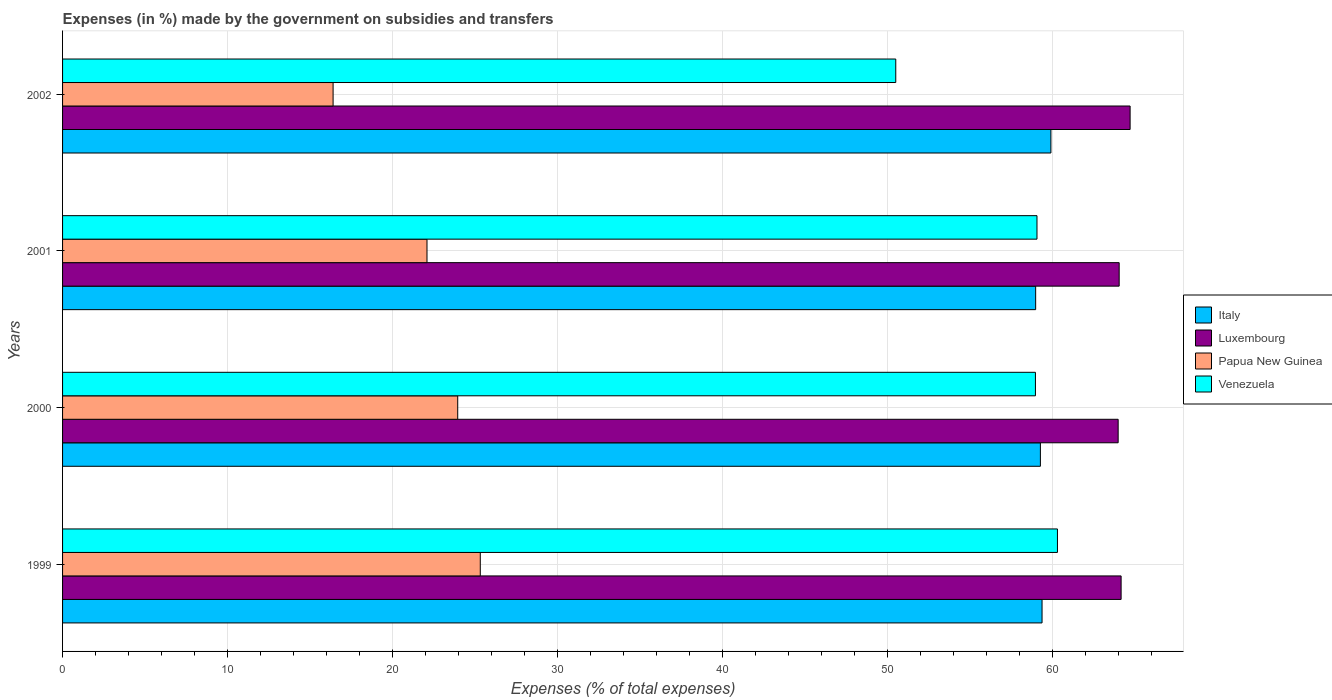How many different coloured bars are there?
Provide a succinct answer. 4. How many groups of bars are there?
Ensure brevity in your answer.  4. How many bars are there on the 3rd tick from the top?
Keep it short and to the point. 4. How many bars are there on the 3rd tick from the bottom?
Make the answer very short. 4. What is the label of the 3rd group of bars from the top?
Your response must be concise. 2000. What is the percentage of expenses made by the government on subsidies and transfers in Luxembourg in 2002?
Provide a succinct answer. 64.71. Across all years, what is the maximum percentage of expenses made by the government on subsidies and transfers in Venezuela?
Your answer should be very brief. 60.3. Across all years, what is the minimum percentage of expenses made by the government on subsidies and transfers in Luxembourg?
Make the answer very short. 63.98. What is the total percentage of expenses made by the government on subsidies and transfers in Papua New Guinea in the graph?
Provide a succinct answer. 87.76. What is the difference between the percentage of expenses made by the government on subsidies and transfers in Italy in 1999 and that in 2000?
Offer a terse response. 0.1. What is the difference between the percentage of expenses made by the government on subsidies and transfers in Papua New Guinea in 2000 and the percentage of expenses made by the government on subsidies and transfers in Italy in 2002?
Your answer should be compact. -35.96. What is the average percentage of expenses made by the government on subsidies and transfers in Luxembourg per year?
Make the answer very short. 64.23. In the year 2001, what is the difference between the percentage of expenses made by the government on subsidies and transfers in Papua New Guinea and percentage of expenses made by the government on subsidies and transfers in Italy?
Keep it short and to the point. -36.89. What is the ratio of the percentage of expenses made by the government on subsidies and transfers in Italy in 1999 to that in 2001?
Ensure brevity in your answer.  1.01. What is the difference between the highest and the second highest percentage of expenses made by the government on subsidies and transfers in Papua New Guinea?
Ensure brevity in your answer.  1.37. What is the difference between the highest and the lowest percentage of expenses made by the government on subsidies and transfers in Venezuela?
Your answer should be compact. 9.8. In how many years, is the percentage of expenses made by the government on subsidies and transfers in Luxembourg greater than the average percentage of expenses made by the government on subsidies and transfers in Luxembourg taken over all years?
Your answer should be compact. 1. Is it the case that in every year, the sum of the percentage of expenses made by the government on subsidies and transfers in Papua New Guinea and percentage of expenses made by the government on subsidies and transfers in Italy is greater than the sum of percentage of expenses made by the government on subsidies and transfers in Venezuela and percentage of expenses made by the government on subsidies and transfers in Luxembourg?
Provide a succinct answer. No. What does the 4th bar from the top in 2001 represents?
Make the answer very short. Italy. How many bars are there?
Give a very brief answer. 16. How many years are there in the graph?
Your answer should be compact. 4. How many legend labels are there?
Your answer should be very brief. 4. How are the legend labels stacked?
Ensure brevity in your answer.  Vertical. What is the title of the graph?
Ensure brevity in your answer.  Expenses (in %) made by the government on subsidies and transfers. Does "Puerto Rico" appear as one of the legend labels in the graph?
Provide a short and direct response. No. What is the label or title of the X-axis?
Offer a very short reply. Expenses (% of total expenses). What is the Expenses (% of total expenses) in Italy in 1999?
Make the answer very short. 59.37. What is the Expenses (% of total expenses) in Luxembourg in 1999?
Your response must be concise. 64.16. What is the Expenses (% of total expenses) in Papua New Guinea in 1999?
Offer a very short reply. 25.32. What is the Expenses (% of total expenses) of Venezuela in 1999?
Keep it short and to the point. 60.3. What is the Expenses (% of total expenses) in Italy in 2000?
Give a very brief answer. 59.27. What is the Expenses (% of total expenses) of Luxembourg in 2000?
Your answer should be compact. 63.98. What is the Expenses (% of total expenses) in Papua New Guinea in 2000?
Make the answer very short. 23.95. What is the Expenses (% of total expenses) in Venezuela in 2000?
Ensure brevity in your answer.  58.97. What is the Expenses (% of total expenses) in Italy in 2001?
Offer a terse response. 58.98. What is the Expenses (% of total expenses) in Luxembourg in 2001?
Offer a very short reply. 64.05. What is the Expenses (% of total expenses) of Papua New Guinea in 2001?
Offer a very short reply. 22.09. What is the Expenses (% of total expenses) in Venezuela in 2001?
Provide a succinct answer. 59.06. What is the Expenses (% of total expenses) of Italy in 2002?
Make the answer very short. 59.91. What is the Expenses (% of total expenses) of Luxembourg in 2002?
Make the answer very short. 64.71. What is the Expenses (% of total expenses) in Papua New Guinea in 2002?
Your answer should be compact. 16.4. What is the Expenses (% of total expenses) in Venezuela in 2002?
Offer a terse response. 50.5. Across all years, what is the maximum Expenses (% of total expenses) in Italy?
Your answer should be very brief. 59.91. Across all years, what is the maximum Expenses (% of total expenses) of Luxembourg?
Your response must be concise. 64.71. Across all years, what is the maximum Expenses (% of total expenses) of Papua New Guinea?
Provide a succinct answer. 25.32. Across all years, what is the maximum Expenses (% of total expenses) of Venezuela?
Give a very brief answer. 60.3. Across all years, what is the minimum Expenses (% of total expenses) of Italy?
Provide a succinct answer. 58.98. Across all years, what is the minimum Expenses (% of total expenses) of Luxembourg?
Ensure brevity in your answer.  63.98. Across all years, what is the minimum Expenses (% of total expenses) of Papua New Guinea?
Ensure brevity in your answer.  16.4. Across all years, what is the minimum Expenses (% of total expenses) in Venezuela?
Your answer should be very brief. 50.5. What is the total Expenses (% of total expenses) of Italy in the graph?
Provide a succinct answer. 237.53. What is the total Expenses (% of total expenses) in Luxembourg in the graph?
Your answer should be very brief. 256.9. What is the total Expenses (% of total expenses) in Papua New Guinea in the graph?
Your answer should be very brief. 87.76. What is the total Expenses (% of total expenses) in Venezuela in the graph?
Give a very brief answer. 228.84. What is the difference between the Expenses (% of total expenses) in Italy in 1999 and that in 2000?
Ensure brevity in your answer.  0.1. What is the difference between the Expenses (% of total expenses) in Luxembourg in 1999 and that in 2000?
Ensure brevity in your answer.  0.18. What is the difference between the Expenses (% of total expenses) in Papua New Guinea in 1999 and that in 2000?
Keep it short and to the point. 1.37. What is the difference between the Expenses (% of total expenses) in Venezuela in 1999 and that in 2000?
Give a very brief answer. 1.33. What is the difference between the Expenses (% of total expenses) in Italy in 1999 and that in 2001?
Offer a terse response. 0.39. What is the difference between the Expenses (% of total expenses) in Luxembourg in 1999 and that in 2001?
Offer a terse response. 0.12. What is the difference between the Expenses (% of total expenses) in Papua New Guinea in 1999 and that in 2001?
Your response must be concise. 3.23. What is the difference between the Expenses (% of total expenses) in Venezuela in 1999 and that in 2001?
Offer a terse response. 1.24. What is the difference between the Expenses (% of total expenses) of Italy in 1999 and that in 2002?
Your answer should be very brief. -0.54. What is the difference between the Expenses (% of total expenses) in Luxembourg in 1999 and that in 2002?
Your response must be concise. -0.55. What is the difference between the Expenses (% of total expenses) in Papua New Guinea in 1999 and that in 2002?
Make the answer very short. 8.92. What is the difference between the Expenses (% of total expenses) of Venezuela in 1999 and that in 2002?
Offer a terse response. 9.8. What is the difference between the Expenses (% of total expenses) of Italy in 2000 and that in 2001?
Offer a very short reply. 0.29. What is the difference between the Expenses (% of total expenses) of Luxembourg in 2000 and that in 2001?
Provide a short and direct response. -0.06. What is the difference between the Expenses (% of total expenses) in Papua New Guinea in 2000 and that in 2001?
Your answer should be compact. 1.86. What is the difference between the Expenses (% of total expenses) in Venezuela in 2000 and that in 2001?
Offer a terse response. -0.09. What is the difference between the Expenses (% of total expenses) of Italy in 2000 and that in 2002?
Offer a very short reply. -0.64. What is the difference between the Expenses (% of total expenses) of Luxembourg in 2000 and that in 2002?
Make the answer very short. -0.73. What is the difference between the Expenses (% of total expenses) of Papua New Guinea in 2000 and that in 2002?
Provide a succinct answer. 7.55. What is the difference between the Expenses (% of total expenses) of Venezuela in 2000 and that in 2002?
Ensure brevity in your answer.  8.47. What is the difference between the Expenses (% of total expenses) in Italy in 2001 and that in 2002?
Offer a very short reply. -0.92. What is the difference between the Expenses (% of total expenses) of Luxembourg in 2001 and that in 2002?
Keep it short and to the point. -0.66. What is the difference between the Expenses (% of total expenses) of Papua New Guinea in 2001 and that in 2002?
Offer a very short reply. 5.69. What is the difference between the Expenses (% of total expenses) of Venezuela in 2001 and that in 2002?
Offer a very short reply. 8.56. What is the difference between the Expenses (% of total expenses) in Italy in 1999 and the Expenses (% of total expenses) in Luxembourg in 2000?
Provide a short and direct response. -4.61. What is the difference between the Expenses (% of total expenses) in Italy in 1999 and the Expenses (% of total expenses) in Papua New Guinea in 2000?
Give a very brief answer. 35.42. What is the difference between the Expenses (% of total expenses) in Italy in 1999 and the Expenses (% of total expenses) in Venezuela in 2000?
Offer a terse response. 0.4. What is the difference between the Expenses (% of total expenses) in Luxembourg in 1999 and the Expenses (% of total expenses) in Papua New Guinea in 2000?
Your answer should be compact. 40.21. What is the difference between the Expenses (% of total expenses) of Luxembourg in 1999 and the Expenses (% of total expenses) of Venezuela in 2000?
Your answer should be very brief. 5.19. What is the difference between the Expenses (% of total expenses) in Papua New Guinea in 1999 and the Expenses (% of total expenses) in Venezuela in 2000?
Provide a short and direct response. -33.65. What is the difference between the Expenses (% of total expenses) of Italy in 1999 and the Expenses (% of total expenses) of Luxembourg in 2001?
Make the answer very short. -4.67. What is the difference between the Expenses (% of total expenses) of Italy in 1999 and the Expenses (% of total expenses) of Papua New Guinea in 2001?
Provide a succinct answer. 37.28. What is the difference between the Expenses (% of total expenses) in Italy in 1999 and the Expenses (% of total expenses) in Venezuela in 2001?
Offer a very short reply. 0.31. What is the difference between the Expenses (% of total expenses) of Luxembourg in 1999 and the Expenses (% of total expenses) of Papua New Guinea in 2001?
Offer a very short reply. 42.07. What is the difference between the Expenses (% of total expenses) of Luxembourg in 1999 and the Expenses (% of total expenses) of Venezuela in 2001?
Offer a very short reply. 5.1. What is the difference between the Expenses (% of total expenses) in Papua New Guinea in 1999 and the Expenses (% of total expenses) in Venezuela in 2001?
Make the answer very short. -33.74. What is the difference between the Expenses (% of total expenses) in Italy in 1999 and the Expenses (% of total expenses) in Luxembourg in 2002?
Make the answer very short. -5.34. What is the difference between the Expenses (% of total expenses) in Italy in 1999 and the Expenses (% of total expenses) in Papua New Guinea in 2002?
Make the answer very short. 42.97. What is the difference between the Expenses (% of total expenses) in Italy in 1999 and the Expenses (% of total expenses) in Venezuela in 2002?
Give a very brief answer. 8.87. What is the difference between the Expenses (% of total expenses) in Luxembourg in 1999 and the Expenses (% of total expenses) in Papua New Guinea in 2002?
Your answer should be compact. 47.77. What is the difference between the Expenses (% of total expenses) in Luxembourg in 1999 and the Expenses (% of total expenses) in Venezuela in 2002?
Keep it short and to the point. 13.66. What is the difference between the Expenses (% of total expenses) in Papua New Guinea in 1999 and the Expenses (% of total expenses) in Venezuela in 2002?
Offer a very short reply. -25.18. What is the difference between the Expenses (% of total expenses) of Italy in 2000 and the Expenses (% of total expenses) of Luxembourg in 2001?
Offer a terse response. -4.78. What is the difference between the Expenses (% of total expenses) in Italy in 2000 and the Expenses (% of total expenses) in Papua New Guinea in 2001?
Keep it short and to the point. 37.18. What is the difference between the Expenses (% of total expenses) of Italy in 2000 and the Expenses (% of total expenses) of Venezuela in 2001?
Ensure brevity in your answer.  0.21. What is the difference between the Expenses (% of total expenses) of Luxembourg in 2000 and the Expenses (% of total expenses) of Papua New Guinea in 2001?
Provide a short and direct response. 41.89. What is the difference between the Expenses (% of total expenses) in Luxembourg in 2000 and the Expenses (% of total expenses) in Venezuela in 2001?
Keep it short and to the point. 4.92. What is the difference between the Expenses (% of total expenses) of Papua New Guinea in 2000 and the Expenses (% of total expenses) of Venezuela in 2001?
Make the answer very short. -35.11. What is the difference between the Expenses (% of total expenses) in Italy in 2000 and the Expenses (% of total expenses) in Luxembourg in 2002?
Your answer should be compact. -5.44. What is the difference between the Expenses (% of total expenses) in Italy in 2000 and the Expenses (% of total expenses) in Papua New Guinea in 2002?
Provide a short and direct response. 42.87. What is the difference between the Expenses (% of total expenses) in Italy in 2000 and the Expenses (% of total expenses) in Venezuela in 2002?
Your answer should be compact. 8.77. What is the difference between the Expenses (% of total expenses) of Luxembourg in 2000 and the Expenses (% of total expenses) of Papua New Guinea in 2002?
Provide a short and direct response. 47.59. What is the difference between the Expenses (% of total expenses) in Luxembourg in 2000 and the Expenses (% of total expenses) in Venezuela in 2002?
Offer a very short reply. 13.48. What is the difference between the Expenses (% of total expenses) in Papua New Guinea in 2000 and the Expenses (% of total expenses) in Venezuela in 2002?
Provide a short and direct response. -26.55. What is the difference between the Expenses (% of total expenses) in Italy in 2001 and the Expenses (% of total expenses) in Luxembourg in 2002?
Make the answer very short. -5.73. What is the difference between the Expenses (% of total expenses) in Italy in 2001 and the Expenses (% of total expenses) in Papua New Guinea in 2002?
Provide a short and direct response. 42.58. What is the difference between the Expenses (% of total expenses) of Italy in 2001 and the Expenses (% of total expenses) of Venezuela in 2002?
Offer a terse response. 8.48. What is the difference between the Expenses (% of total expenses) in Luxembourg in 2001 and the Expenses (% of total expenses) in Papua New Guinea in 2002?
Your answer should be very brief. 47.65. What is the difference between the Expenses (% of total expenses) of Luxembourg in 2001 and the Expenses (% of total expenses) of Venezuela in 2002?
Ensure brevity in your answer.  13.54. What is the difference between the Expenses (% of total expenses) of Papua New Guinea in 2001 and the Expenses (% of total expenses) of Venezuela in 2002?
Provide a succinct answer. -28.41. What is the average Expenses (% of total expenses) in Italy per year?
Your answer should be compact. 59.38. What is the average Expenses (% of total expenses) in Luxembourg per year?
Provide a short and direct response. 64.23. What is the average Expenses (% of total expenses) of Papua New Guinea per year?
Give a very brief answer. 21.94. What is the average Expenses (% of total expenses) in Venezuela per year?
Give a very brief answer. 57.21. In the year 1999, what is the difference between the Expenses (% of total expenses) in Italy and Expenses (% of total expenses) in Luxembourg?
Give a very brief answer. -4.79. In the year 1999, what is the difference between the Expenses (% of total expenses) of Italy and Expenses (% of total expenses) of Papua New Guinea?
Keep it short and to the point. 34.05. In the year 1999, what is the difference between the Expenses (% of total expenses) of Italy and Expenses (% of total expenses) of Venezuela?
Offer a terse response. -0.93. In the year 1999, what is the difference between the Expenses (% of total expenses) of Luxembourg and Expenses (% of total expenses) of Papua New Guinea?
Make the answer very short. 38.84. In the year 1999, what is the difference between the Expenses (% of total expenses) of Luxembourg and Expenses (% of total expenses) of Venezuela?
Give a very brief answer. 3.86. In the year 1999, what is the difference between the Expenses (% of total expenses) of Papua New Guinea and Expenses (% of total expenses) of Venezuela?
Offer a terse response. -34.99. In the year 2000, what is the difference between the Expenses (% of total expenses) in Italy and Expenses (% of total expenses) in Luxembourg?
Make the answer very short. -4.71. In the year 2000, what is the difference between the Expenses (% of total expenses) of Italy and Expenses (% of total expenses) of Papua New Guinea?
Keep it short and to the point. 35.32. In the year 2000, what is the difference between the Expenses (% of total expenses) in Italy and Expenses (% of total expenses) in Venezuela?
Offer a very short reply. 0.3. In the year 2000, what is the difference between the Expenses (% of total expenses) of Luxembourg and Expenses (% of total expenses) of Papua New Guinea?
Provide a succinct answer. 40.03. In the year 2000, what is the difference between the Expenses (% of total expenses) of Luxembourg and Expenses (% of total expenses) of Venezuela?
Offer a terse response. 5.01. In the year 2000, what is the difference between the Expenses (% of total expenses) in Papua New Guinea and Expenses (% of total expenses) in Venezuela?
Offer a terse response. -35.02. In the year 2001, what is the difference between the Expenses (% of total expenses) in Italy and Expenses (% of total expenses) in Luxembourg?
Provide a succinct answer. -5.06. In the year 2001, what is the difference between the Expenses (% of total expenses) in Italy and Expenses (% of total expenses) in Papua New Guinea?
Your response must be concise. 36.89. In the year 2001, what is the difference between the Expenses (% of total expenses) of Italy and Expenses (% of total expenses) of Venezuela?
Offer a terse response. -0.08. In the year 2001, what is the difference between the Expenses (% of total expenses) in Luxembourg and Expenses (% of total expenses) in Papua New Guinea?
Provide a short and direct response. 41.96. In the year 2001, what is the difference between the Expenses (% of total expenses) of Luxembourg and Expenses (% of total expenses) of Venezuela?
Give a very brief answer. 4.98. In the year 2001, what is the difference between the Expenses (% of total expenses) in Papua New Guinea and Expenses (% of total expenses) in Venezuela?
Provide a succinct answer. -36.97. In the year 2002, what is the difference between the Expenses (% of total expenses) of Italy and Expenses (% of total expenses) of Luxembourg?
Offer a terse response. -4.8. In the year 2002, what is the difference between the Expenses (% of total expenses) of Italy and Expenses (% of total expenses) of Papua New Guinea?
Make the answer very short. 43.51. In the year 2002, what is the difference between the Expenses (% of total expenses) of Italy and Expenses (% of total expenses) of Venezuela?
Your response must be concise. 9.4. In the year 2002, what is the difference between the Expenses (% of total expenses) of Luxembourg and Expenses (% of total expenses) of Papua New Guinea?
Offer a very short reply. 48.31. In the year 2002, what is the difference between the Expenses (% of total expenses) in Luxembourg and Expenses (% of total expenses) in Venezuela?
Your response must be concise. 14.2. In the year 2002, what is the difference between the Expenses (% of total expenses) of Papua New Guinea and Expenses (% of total expenses) of Venezuela?
Ensure brevity in your answer.  -34.11. What is the ratio of the Expenses (% of total expenses) in Italy in 1999 to that in 2000?
Make the answer very short. 1. What is the ratio of the Expenses (% of total expenses) in Luxembourg in 1999 to that in 2000?
Your answer should be compact. 1. What is the ratio of the Expenses (% of total expenses) of Papua New Guinea in 1999 to that in 2000?
Give a very brief answer. 1.06. What is the ratio of the Expenses (% of total expenses) of Venezuela in 1999 to that in 2000?
Ensure brevity in your answer.  1.02. What is the ratio of the Expenses (% of total expenses) of Italy in 1999 to that in 2001?
Provide a short and direct response. 1.01. What is the ratio of the Expenses (% of total expenses) of Papua New Guinea in 1999 to that in 2001?
Offer a very short reply. 1.15. What is the ratio of the Expenses (% of total expenses) of Venezuela in 1999 to that in 2001?
Keep it short and to the point. 1.02. What is the ratio of the Expenses (% of total expenses) in Italy in 1999 to that in 2002?
Offer a very short reply. 0.99. What is the ratio of the Expenses (% of total expenses) of Papua New Guinea in 1999 to that in 2002?
Your answer should be very brief. 1.54. What is the ratio of the Expenses (% of total expenses) in Venezuela in 1999 to that in 2002?
Keep it short and to the point. 1.19. What is the ratio of the Expenses (% of total expenses) of Italy in 2000 to that in 2001?
Your response must be concise. 1. What is the ratio of the Expenses (% of total expenses) in Papua New Guinea in 2000 to that in 2001?
Your answer should be compact. 1.08. What is the ratio of the Expenses (% of total expenses) of Venezuela in 2000 to that in 2001?
Offer a very short reply. 1. What is the ratio of the Expenses (% of total expenses) of Italy in 2000 to that in 2002?
Give a very brief answer. 0.99. What is the ratio of the Expenses (% of total expenses) in Luxembourg in 2000 to that in 2002?
Your response must be concise. 0.99. What is the ratio of the Expenses (% of total expenses) of Papua New Guinea in 2000 to that in 2002?
Ensure brevity in your answer.  1.46. What is the ratio of the Expenses (% of total expenses) of Venezuela in 2000 to that in 2002?
Offer a terse response. 1.17. What is the ratio of the Expenses (% of total expenses) of Italy in 2001 to that in 2002?
Offer a terse response. 0.98. What is the ratio of the Expenses (% of total expenses) in Papua New Guinea in 2001 to that in 2002?
Give a very brief answer. 1.35. What is the ratio of the Expenses (% of total expenses) in Venezuela in 2001 to that in 2002?
Offer a very short reply. 1.17. What is the difference between the highest and the second highest Expenses (% of total expenses) in Italy?
Provide a short and direct response. 0.54. What is the difference between the highest and the second highest Expenses (% of total expenses) of Luxembourg?
Your answer should be very brief. 0.55. What is the difference between the highest and the second highest Expenses (% of total expenses) of Papua New Guinea?
Make the answer very short. 1.37. What is the difference between the highest and the second highest Expenses (% of total expenses) in Venezuela?
Ensure brevity in your answer.  1.24. What is the difference between the highest and the lowest Expenses (% of total expenses) in Italy?
Your answer should be very brief. 0.92. What is the difference between the highest and the lowest Expenses (% of total expenses) of Luxembourg?
Provide a short and direct response. 0.73. What is the difference between the highest and the lowest Expenses (% of total expenses) in Papua New Guinea?
Offer a very short reply. 8.92. What is the difference between the highest and the lowest Expenses (% of total expenses) in Venezuela?
Ensure brevity in your answer.  9.8. 